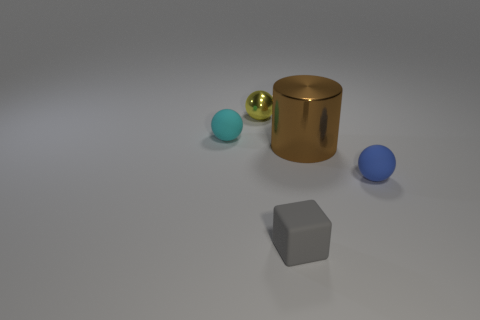Are there more metal balls that are left of the tiny yellow sphere than yellow balls? Actually, the image doesn't contain any yellow balls. There is a small yellow sphere to the left of which we can see two metal balls. So, there are indeed more metal balls to the left of the tiny yellow sphere than yellow balls, primarily because there aren't any yellow balls at all. 